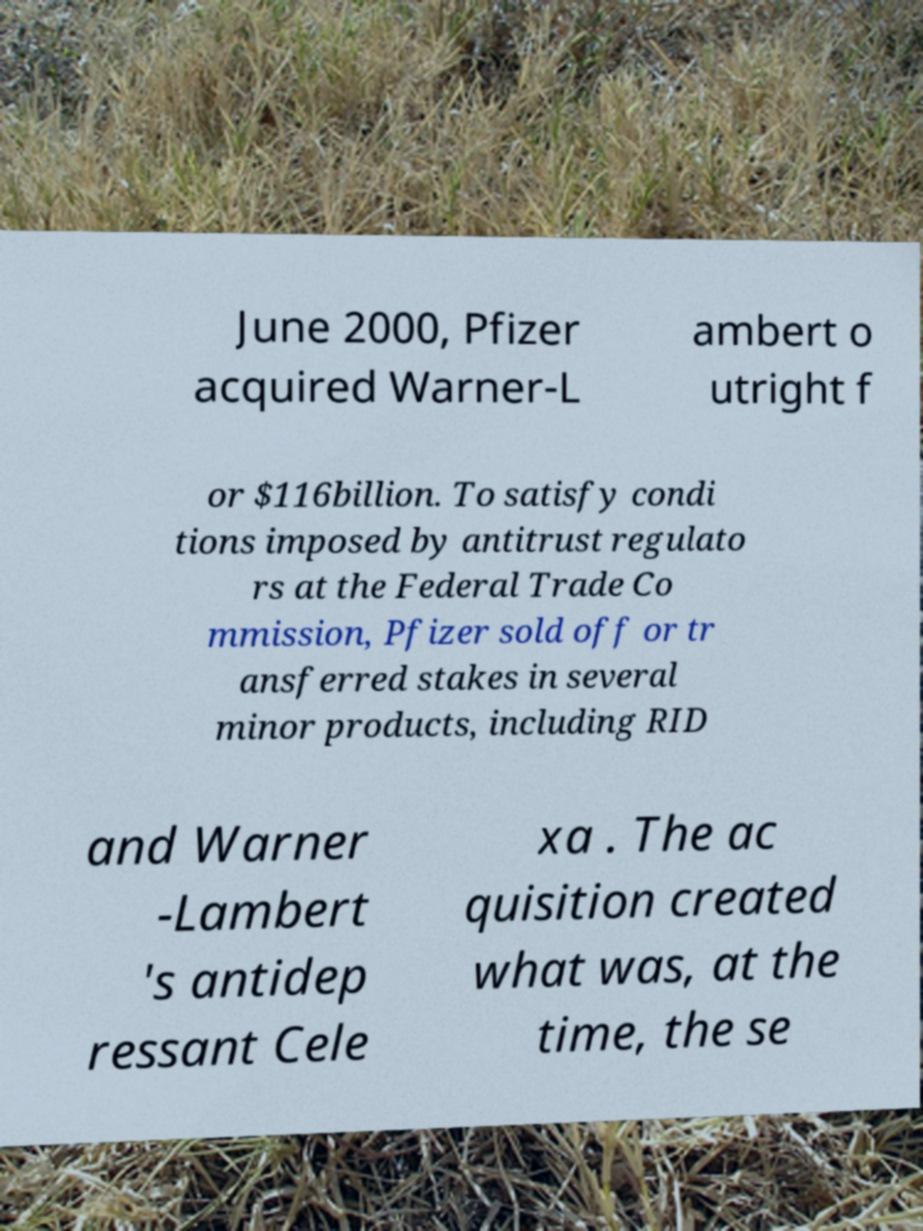Can you read and provide the text displayed in the image?This photo seems to have some interesting text. Can you extract and type it out for me? June 2000, Pfizer acquired Warner-L ambert o utright f or $116billion. To satisfy condi tions imposed by antitrust regulato rs at the Federal Trade Co mmission, Pfizer sold off or tr ansferred stakes in several minor products, including RID and Warner -Lambert 's antidep ressant Cele xa . The ac quisition created what was, at the time, the se 